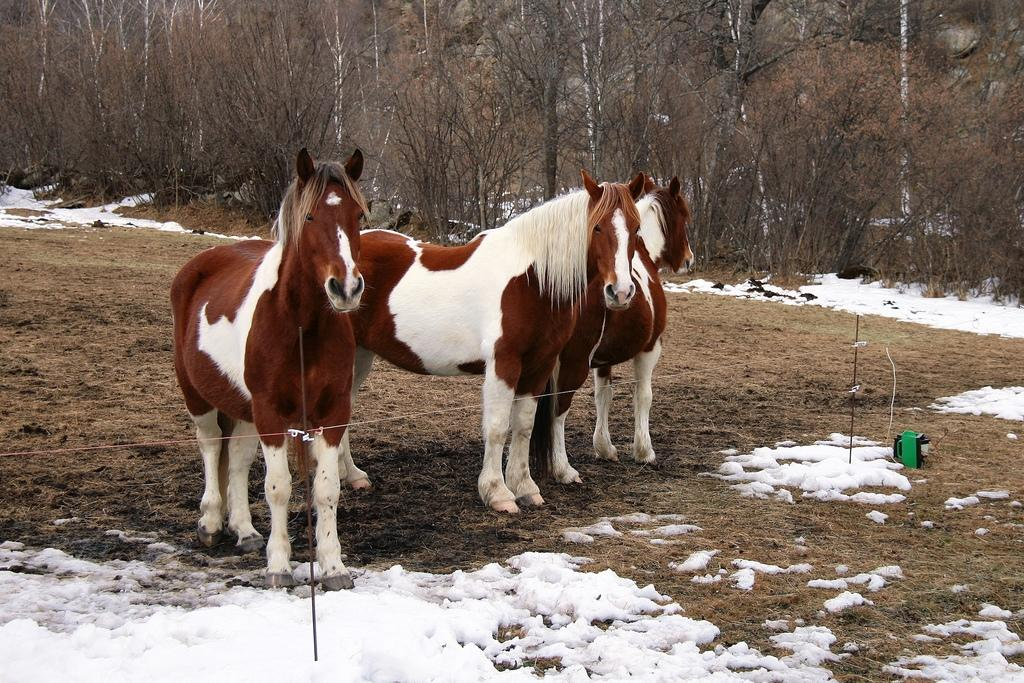What type of vegetation can be seen on the path in the image? There are trees on the path in the image. What is the green object on the path? Unfortunately, the facts provided do not give enough information to identify the green object on the path. What is the weather like in the image? Snow is visible in the image, which suggests a cold or wintry weather condition. What can be seen in the background of the image? There are trees in the background of the image. What type of silk material is draped over the trees in the image? There is no silk material present in the image; it features trees on a path with snow visible. How does the wrench help with the observation of the trees in the image? There is no wrench present in the image, and therefore it cannot be used to help with any observations. 